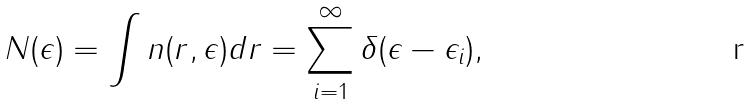<formula> <loc_0><loc_0><loc_500><loc_500>N ( \epsilon ) = \int n ( { r } , \epsilon ) d { r } = \sum _ { i = 1 } ^ { \infty } \delta ( \epsilon - \epsilon _ { i } ) ,</formula> 